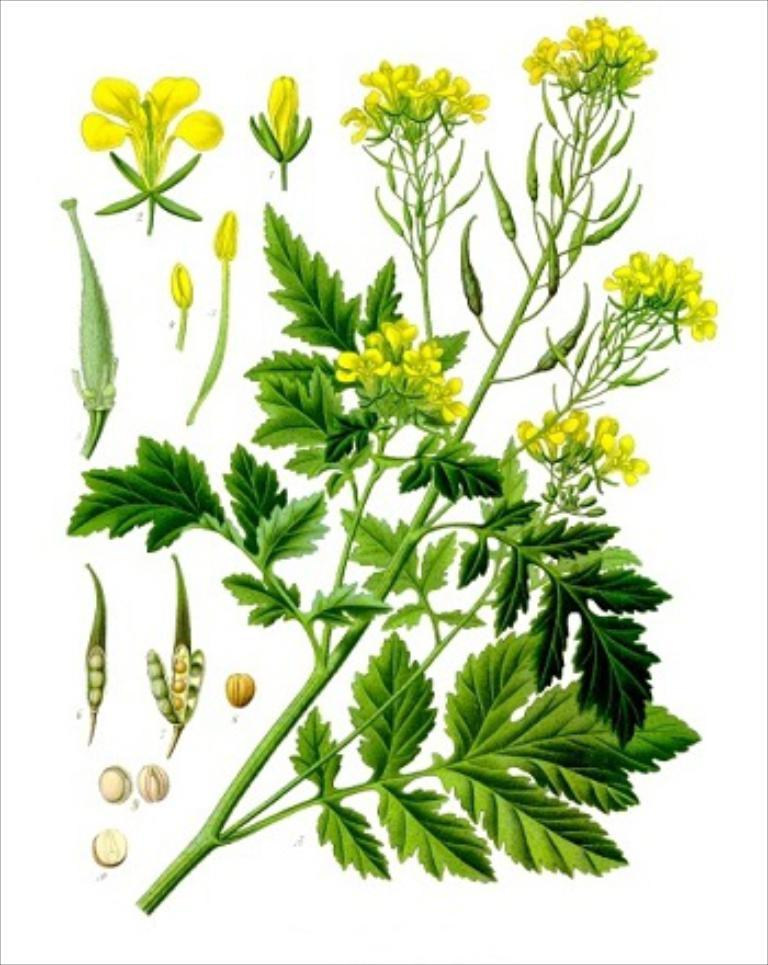What is the main subject of the images in the picture? The main subjects of the images in the picture are a plant, flowers, and seeds. What can be seen in the background of the image? The background of the image is white. What type of furniture is visible in the image? There is no furniture present in the image; it only contains pictures of a plant, flowers, and seeds with a white background. 